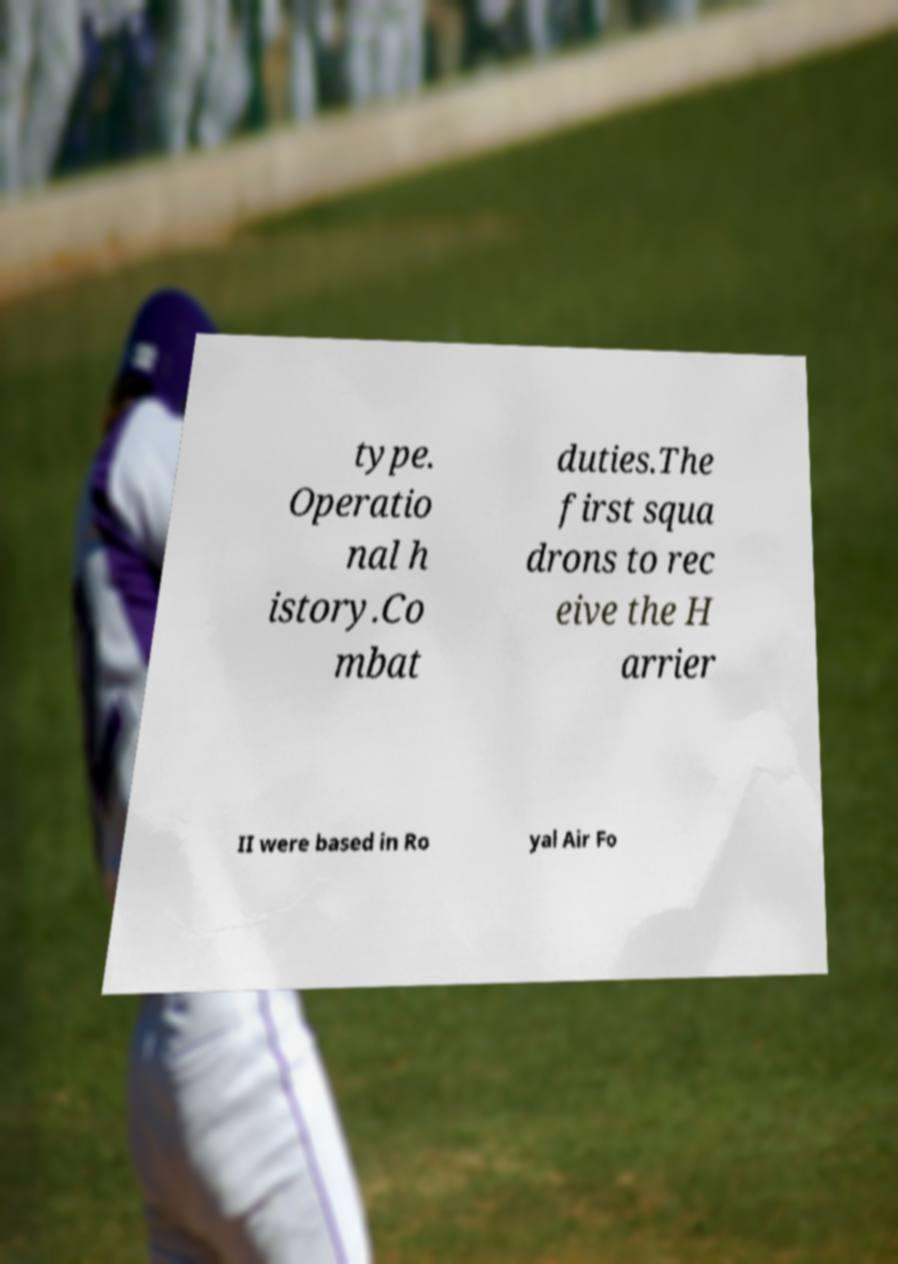Please read and relay the text visible in this image. What does it say? type. Operatio nal h istory.Co mbat duties.The first squa drons to rec eive the H arrier II were based in Ro yal Air Fo 